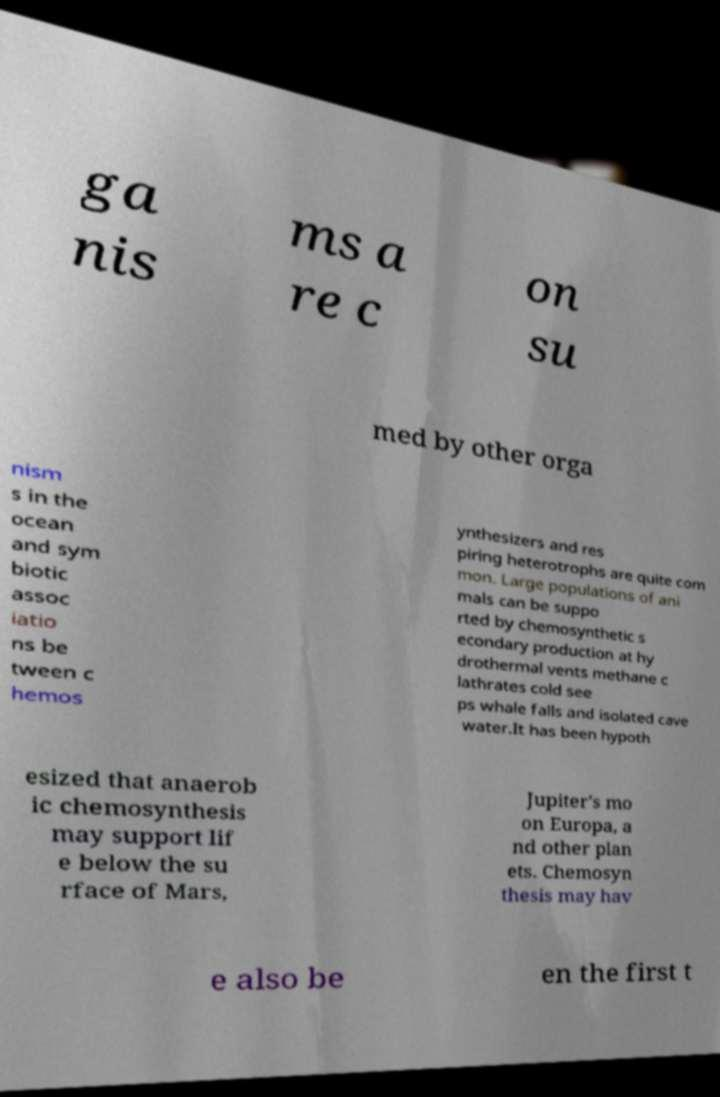Can you read and provide the text displayed in the image?This photo seems to have some interesting text. Can you extract and type it out for me? ga nis ms a re c on su med by other orga nism s in the ocean and sym biotic assoc iatio ns be tween c hemos ynthesizers and res piring heterotrophs are quite com mon. Large populations of ani mals can be suppo rted by chemosynthetic s econdary production at hy drothermal vents methane c lathrates cold see ps whale falls and isolated cave water.It has been hypoth esized that anaerob ic chemosynthesis may support lif e below the su rface of Mars, Jupiter's mo on Europa, a nd other plan ets. Chemosyn thesis may hav e also be en the first t 